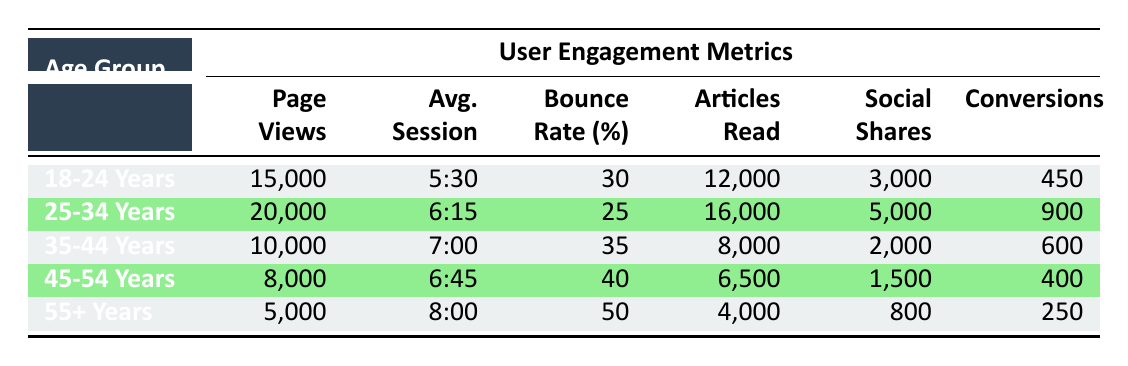What is the bounce rate for the 18-24 years demographic segment? The table lists the bounce rate for the 18-24 years demographic segment in the column labeled 'Bounce Rate (%)'. The value is 30.
Answer: 30 Which demographic segment has the highest average session duration? In the 'Avg. Session' column, the values are 5:30, 6:15, 7:00, 6:45, and 8:00 for the respective segments. Comparing these values shows that the 55+ years segment has the highest duration of 8:00.
Answer: 55+ Years How many articles were read by the 25-34 years demographic segment? The 'Articles Read' column indicates that the 25-34 years demographic segment read 16,000 articles.
Answer: 16,000 What is the total number of conversions for all demographic segments combined? To find the total number of conversions, sum the conversions in the last column: 450 + 900 + 600 + 400 + 250 = 2600.
Answer: 2600 True or False: The 45-54 years demographic segment had more social shares than the 35-44 years segment. The social shares for the 45-54 years segment is 1,500, while it is 2,000 for the 35-44 years segment. Since 1,500 is less than 2,000, the statement is false.
Answer: False Which demographic segment has the highest number of page views? In the 'Page Views' column, the values are 15,000, 20,000, 10,000, 8,000, and 5,000. The highest value is 20,000 corresponding to the 25-34 years demographic segment.
Answer: 25-34 Years What is the average bounce rate across all demographic segments? To find the average bounce rate, sum the bounce rates: 30 + 25 + 35 + 40 + 50 = 180 and then divide by the number of segments (5). The average bounce rate is 180 / 5 = 36.
Answer: 36 How many fewer conversions did the 55+ years demographic segment have compared to the 25-34 years segment? The conversions for the 55+ years segment is 250, and for the 25-34 years segment, it is 900. The difference is 900 - 250 = 650.
Answer: 650 